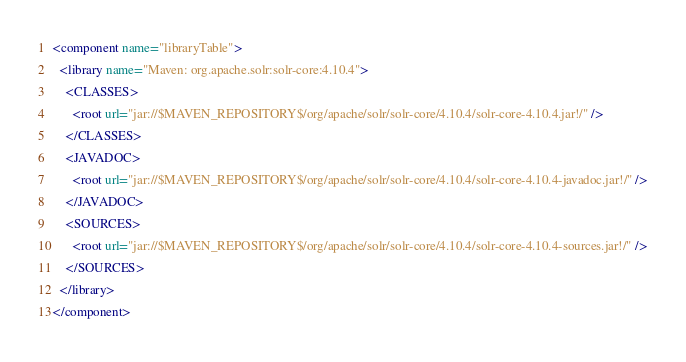<code> <loc_0><loc_0><loc_500><loc_500><_XML_><component name="libraryTable">
  <library name="Maven: org.apache.solr:solr-core:4.10.4">
    <CLASSES>
      <root url="jar://$MAVEN_REPOSITORY$/org/apache/solr/solr-core/4.10.4/solr-core-4.10.4.jar!/" />
    </CLASSES>
    <JAVADOC>
      <root url="jar://$MAVEN_REPOSITORY$/org/apache/solr/solr-core/4.10.4/solr-core-4.10.4-javadoc.jar!/" />
    </JAVADOC>
    <SOURCES>
      <root url="jar://$MAVEN_REPOSITORY$/org/apache/solr/solr-core/4.10.4/solr-core-4.10.4-sources.jar!/" />
    </SOURCES>
  </library>
</component></code> 